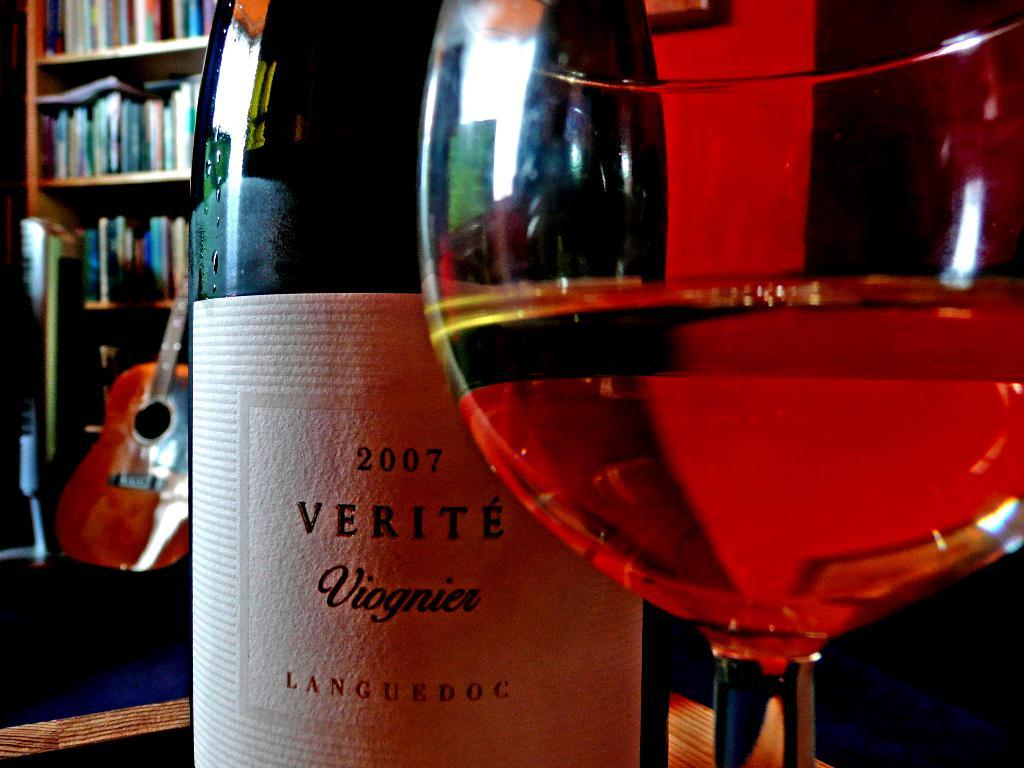<image>
Relay a brief, clear account of the picture shown. A bottle of wine from the year 2007 sits behind a full wine glass. 